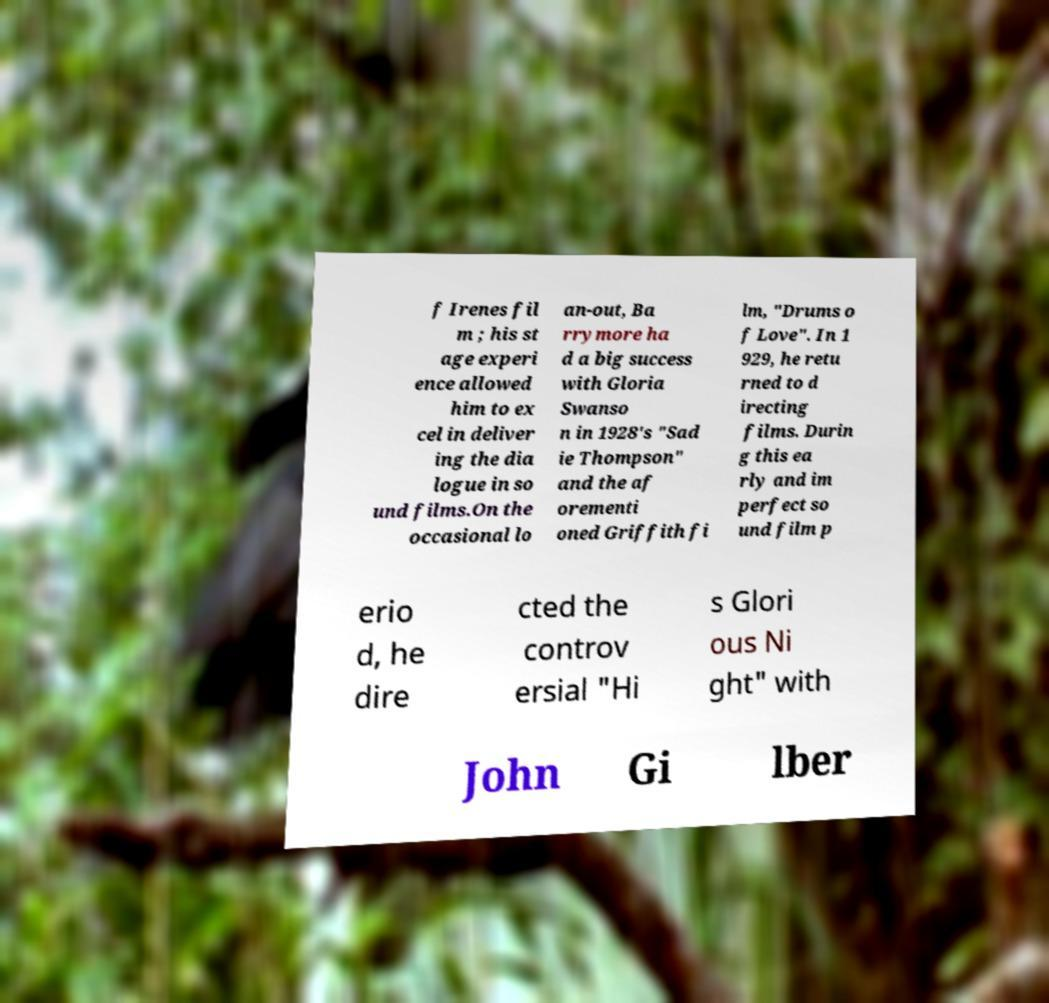Can you accurately transcribe the text from the provided image for me? f Irenes fil m ; his st age experi ence allowed him to ex cel in deliver ing the dia logue in so und films.On the occasional lo an-out, Ba rrymore ha d a big success with Gloria Swanso n in 1928's "Sad ie Thompson" and the af orementi oned Griffith fi lm, "Drums o f Love". In 1 929, he retu rned to d irecting films. Durin g this ea rly and im perfect so und film p erio d, he dire cted the controv ersial "Hi s Glori ous Ni ght" with John Gi lber 